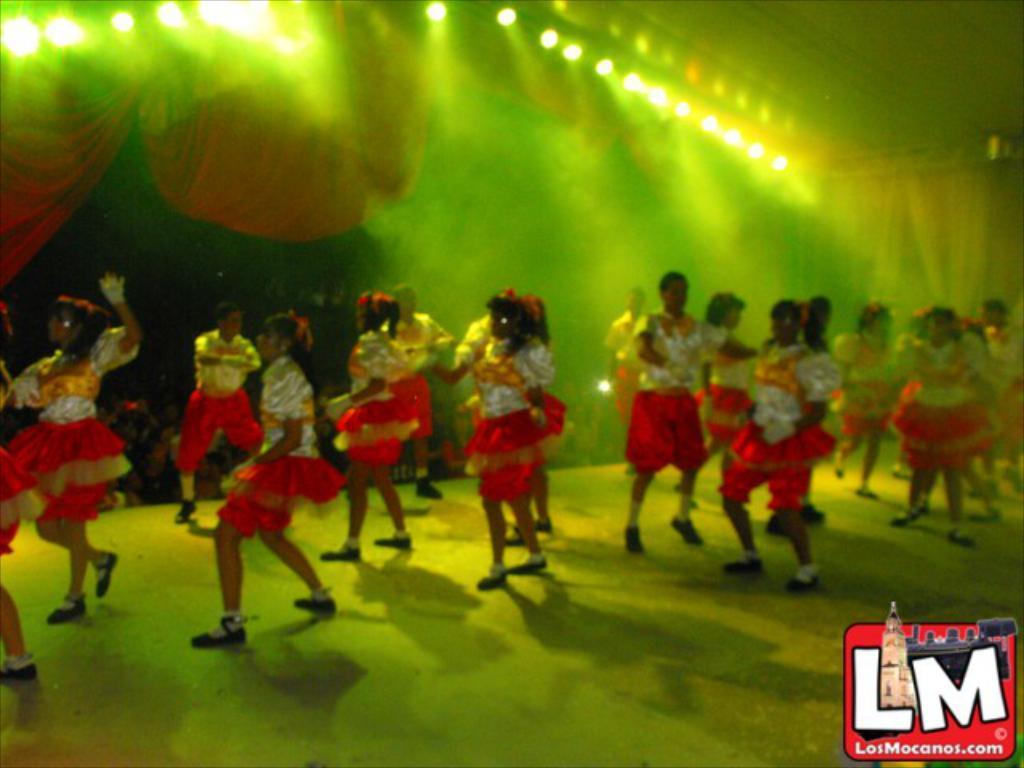Could you give a brief overview of what you see in this image? In the picture we can see some girls are dancing on the dance floor under the shed and to the shed we can see lights which are focused on the girls and outside of the shed we can see some people are watching them and to the shed we can see a red color curtain. 